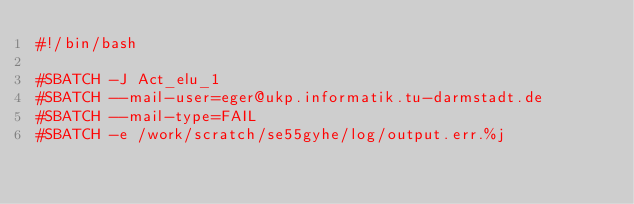Convert code to text. <code><loc_0><loc_0><loc_500><loc_500><_Bash_>#!/bin/bash
 
#SBATCH -J Act_elu_1
#SBATCH --mail-user=eger@ukp.informatik.tu-darmstadt.de
#SBATCH --mail-type=FAIL
#SBATCH -e /work/scratch/se55gyhe/log/output.err.%j</code> 